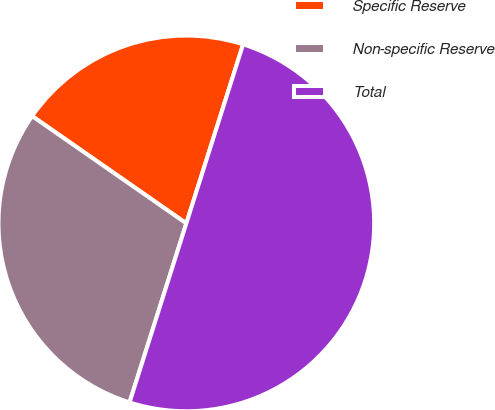Convert chart to OTSL. <chart><loc_0><loc_0><loc_500><loc_500><pie_chart><fcel>Specific Reserve<fcel>Non-specific Reserve<fcel>Total<nl><fcel>20.21%<fcel>29.79%<fcel>50.0%<nl></chart> 